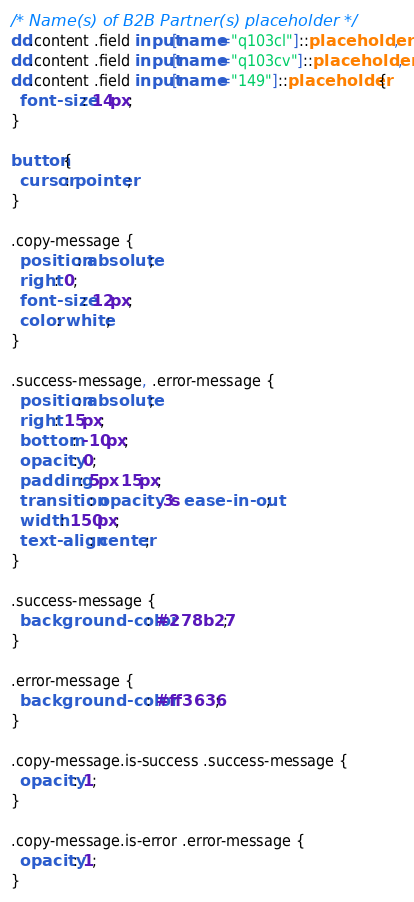<code> <loc_0><loc_0><loc_500><loc_500><_CSS_>/* Name(s) of B2B Partner(s) placeholder */ 
dd.content .field input[name="q103cl"]::placeholder,
dd.content .field input[name="q103cv"]::placeholder,
dd.content .field input[name="149"]::placeholder {
  font-size: 14px;
}

button {
  cursor: pointer;
}

.copy-message {
  position: absolute;
  right: 0;
  font-size: 12px;
  color: white;
}

.success-message, .error-message {
  position: absolute;
  right: 15px;
  bottom: -10px;
  opacity: 0;
  padding: 5px 15px;
  transition: opacity .3s ease-in-out;
  width: 150px;
  text-align: center;
}

.success-message {
  background-color: #278b27;
}

.error-message {
  background-color: #ff3636;
}

.copy-message.is-success .success-message {
  opacity: 1;
}

.copy-message.is-error .error-message {
  opacity: 1;
}</code> 